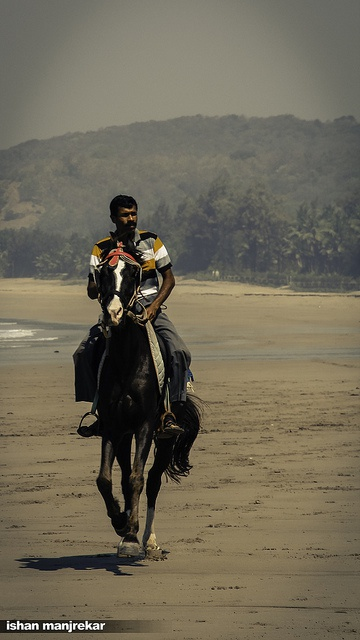Describe the objects in this image and their specific colors. I can see horse in gray, black, and tan tones and people in gray, black, tan, and maroon tones in this image. 